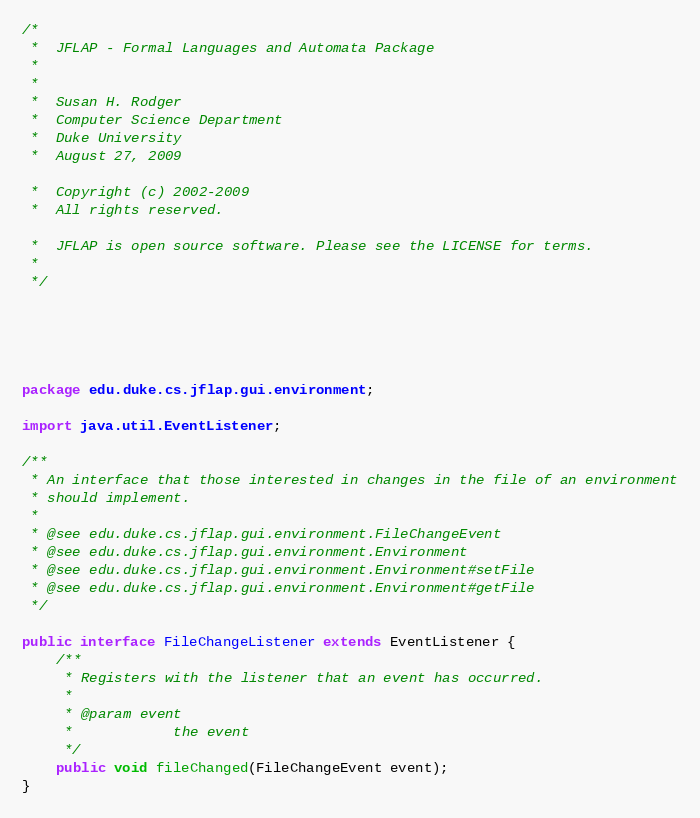<code> <loc_0><loc_0><loc_500><loc_500><_Java_>/*
 *  JFLAP - Formal Languages and Automata Package
 * 
 * 
 *  Susan H. Rodger
 *  Computer Science Department
 *  Duke University
 *  August 27, 2009

 *  Copyright (c) 2002-2009
 *  All rights reserved.

 *  JFLAP is open source software. Please see the LICENSE for terms.
 *
 */





package edu.duke.cs.jflap.gui.environment;

import java.util.EventListener;

/**
 * An interface that those interested in changes in the file of an environment
 * should implement.
 * 
 * @see edu.duke.cs.jflap.gui.environment.FileChangeEvent
 * @see edu.duke.cs.jflap.gui.environment.Environment
 * @see edu.duke.cs.jflap.gui.environment.Environment#setFile
 * @see edu.duke.cs.jflap.gui.environment.Environment#getFile
 */

public interface FileChangeListener extends EventListener {
	/**
	 * Registers with the listener that an event has occurred.
	 * 
	 * @param event
	 *            the event
	 */
	public void fileChanged(FileChangeEvent event);
}
</code> 